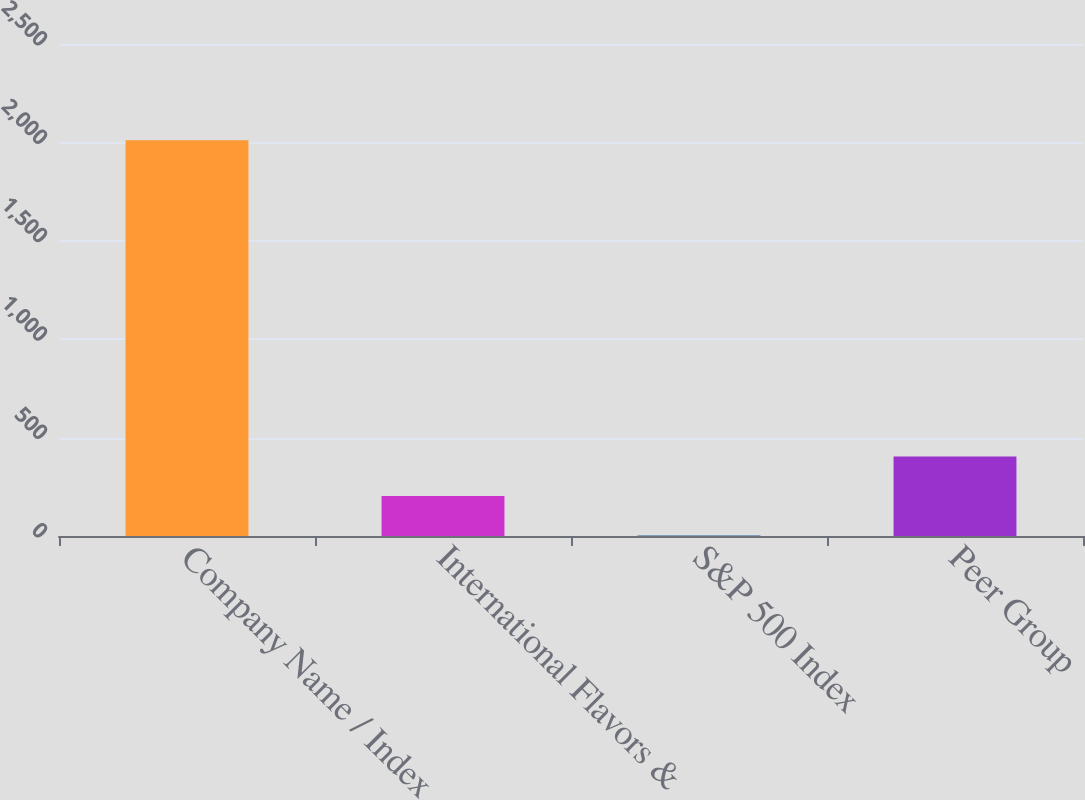Convert chart to OTSL. <chart><loc_0><loc_0><loc_500><loc_500><bar_chart><fcel>Company Name / Index<fcel>International Flavors &<fcel>S&P 500 Index<fcel>Peer Group<nl><fcel>2011<fcel>203<fcel>2.11<fcel>403.89<nl></chart> 